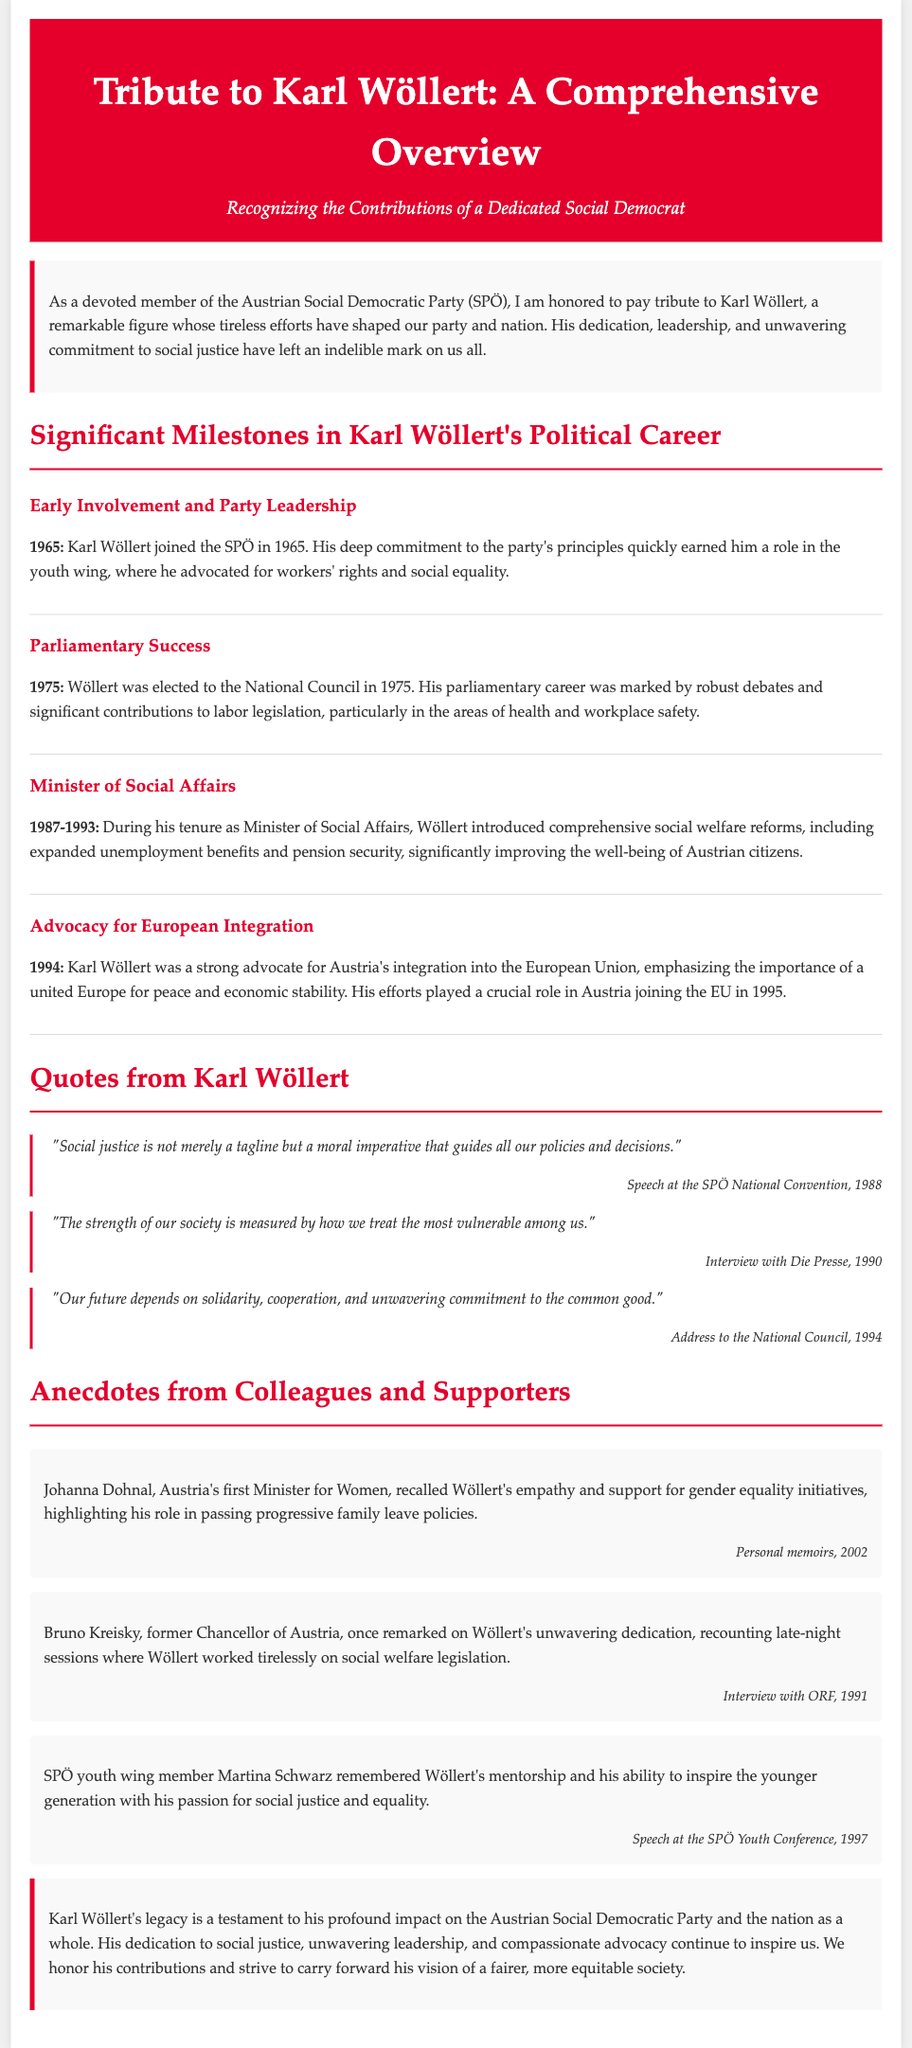What year did Karl Wöllert join the SPÖ? The document specifies that Karl Wöllert joined the SPÖ in 1965.
Answer: 1965 Who was Minister of Social Affairs from 1987 to 1993? The document states that Karl Wöllert served as Minister of Social Affairs during this period.
Answer: Karl Wöllert What significant political event occurred in Austria in 1995? The document mentions that Austria joined the EU in 1995, which was influenced by Wöllert's advocacy.
Answer: Joined the EU Which social issue did Wöllert focus on during his parliamentary career? The document highlights Wöllert's significant contributions to labor legislation, particularly in health and workplace safety.
Answer: Labor legislation What quote from Karl Wöllert emphasizes social justice? The document quotes Wöllert stating that "Social justice is not merely a tagline but a moral imperative that guides all our policies and decisions."
Answer: "Social justice is not merely a tagline but a moral imperative..." What role did Johanna Dohnal have in relation to Karl Wöllert? The document mentions that Johanna Dohnal recalled Wöllert's support for gender equality as Austria's first Minister for Women.
Answer: Minister for Women Which leader remarked on Wöllert's late-night work sessions? The document notes that Bruno Kreisky remarked on Wöllert's dedication, recounting late-night sessions on social welfare legislation.
Answer: Bruno Kreisky What year did Wöllert give a notable speech at the SPÖ National Convention? The document indicates that Wöllert delivered a speech at the SPÖ National Convention in 1988.
Answer: 1988 